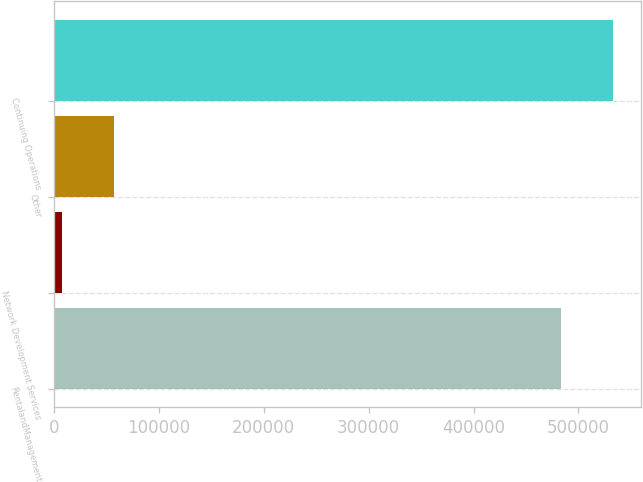Convert chart to OTSL. <chart><loc_0><loc_0><loc_500><loc_500><bar_chart><fcel>RentalandManagement<fcel>Network Development Services<fcel>Other<fcel>Continuing Operations<nl><fcel>483699<fcel>7893<fcel>57531.5<fcel>533338<nl></chart> 